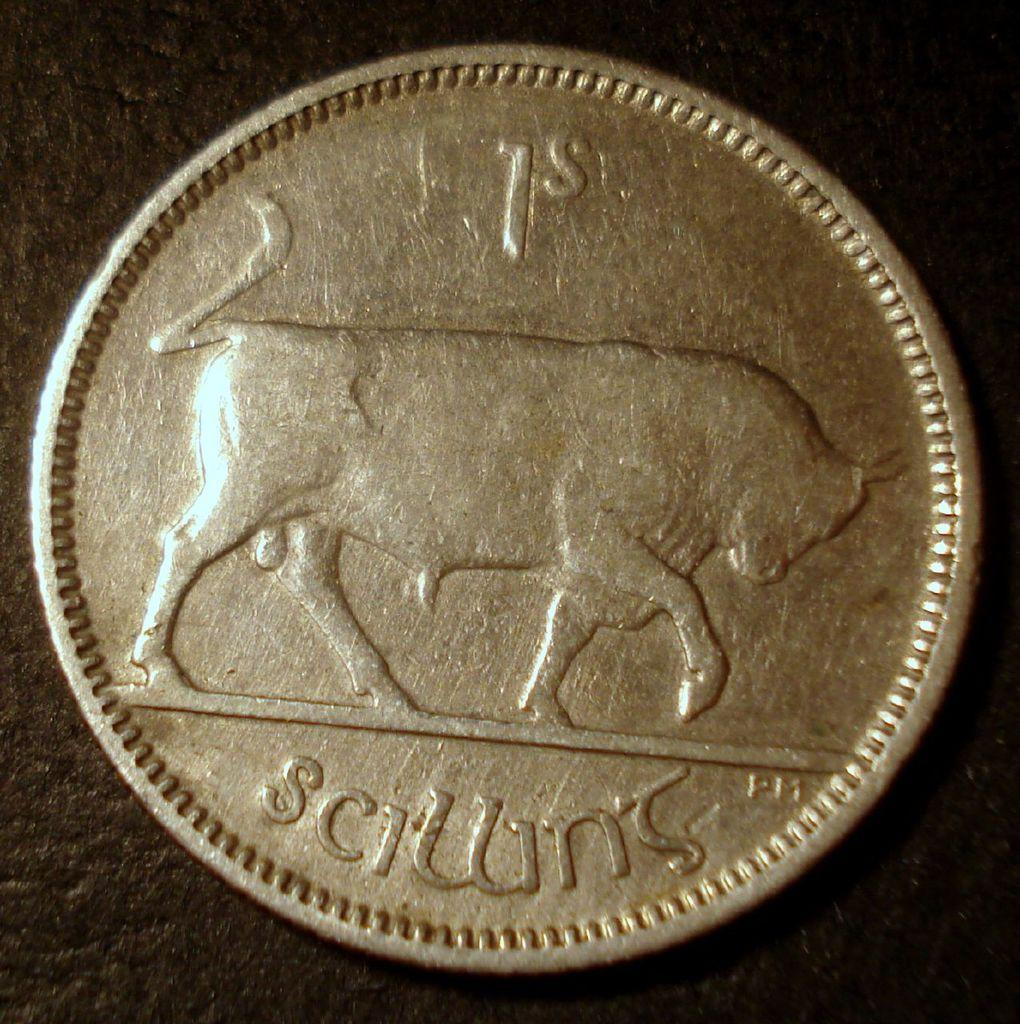<image>
Share a concise interpretation of the image provided. A silver coin has a bull on it and says Sciwns. 